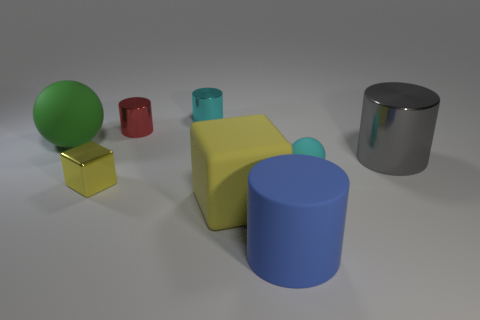Subtract 1 cylinders. How many cylinders are left? 3 Add 1 red metallic cylinders. How many objects exist? 9 Subtract all cubes. How many objects are left? 6 Add 2 red metallic cylinders. How many red metallic cylinders exist? 3 Subtract 0 brown spheres. How many objects are left? 8 Subtract all big blue cylinders. Subtract all cylinders. How many objects are left? 3 Add 4 small yellow metallic cubes. How many small yellow metallic cubes are left? 5 